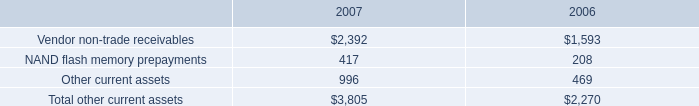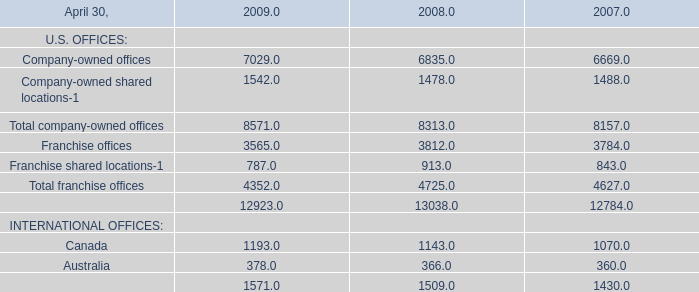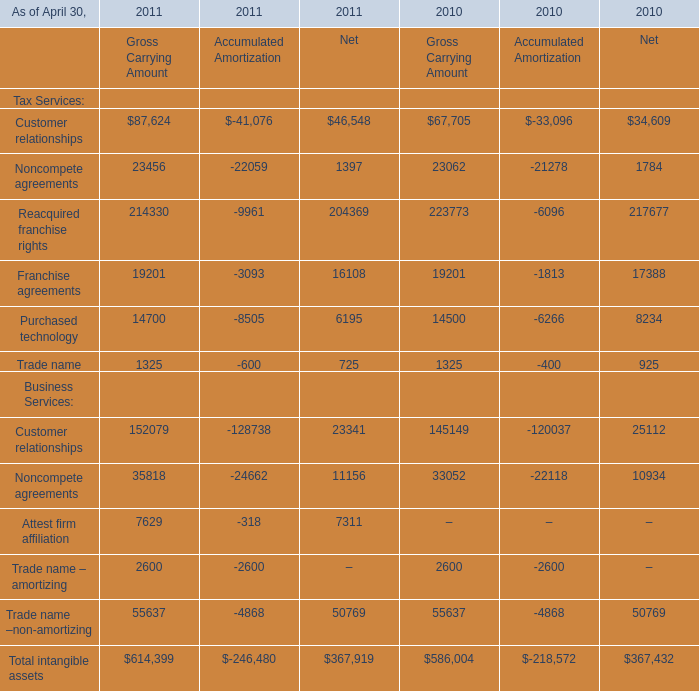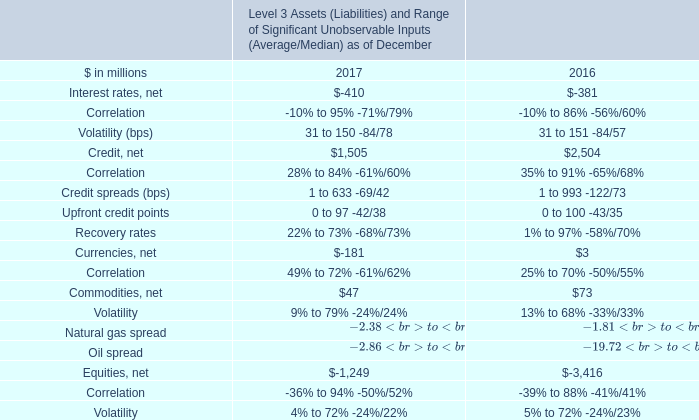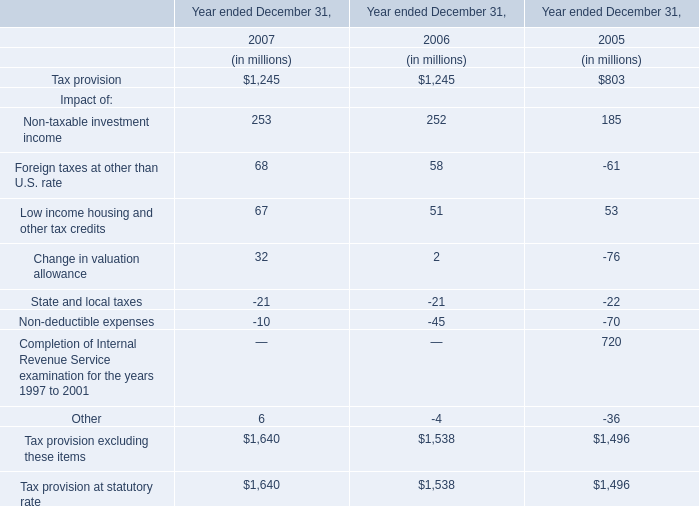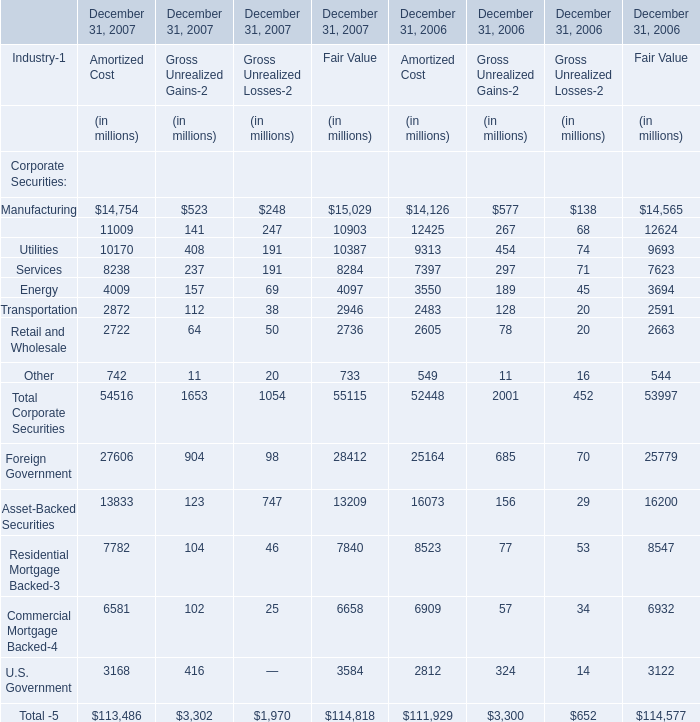If Trade name for Net develops with the same increasing rate in 2011, what will it reach in 2010? 
Computations: (725 * (1 + ((725 - 925) / 925)))
Answer: 568.24324. 